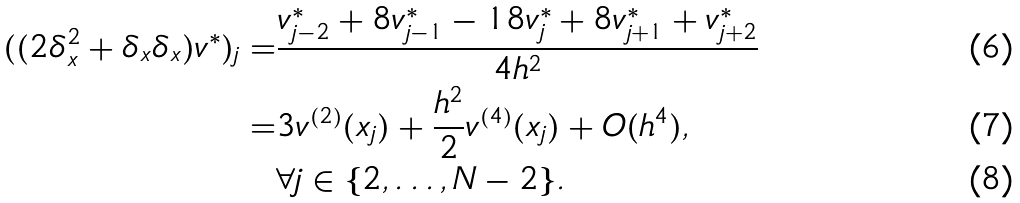<formula> <loc_0><loc_0><loc_500><loc_500>( ( 2 \delta _ { x } ^ { 2 } + \delta _ { x } \delta _ { x } ) v ^ { \ast } ) _ { j } = & \frac { v ^ { \ast } _ { j - 2 } + 8 v ^ { \ast } _ { j - 1 } - 1 8 v ^ { \ast } _ { j } + 8 v ^ { \ast } _ { j + 1 } + v ^ { \ast } _ { j + 2 } } { 4 h ^ { 2 } } \\ = & 3 v ^ { ( 2 ) } ( x _ { j } ) + \frac { h ^ { 2 } } { 2 } v ^ { ( 4 ) } ( x _ { j } ) + O ( h ^ { 4 } ) , \\ & \forall j \in \{ 2 , \dots , N - 2 \} .</formula> 